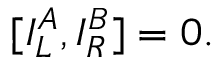Convert formula to latex. <formula><loc_0><loc_0><loc_500><loc_500>[ { I _ { L } ^ { A } , I _ { R } ^ { B } ] } = 0 .</formula> 